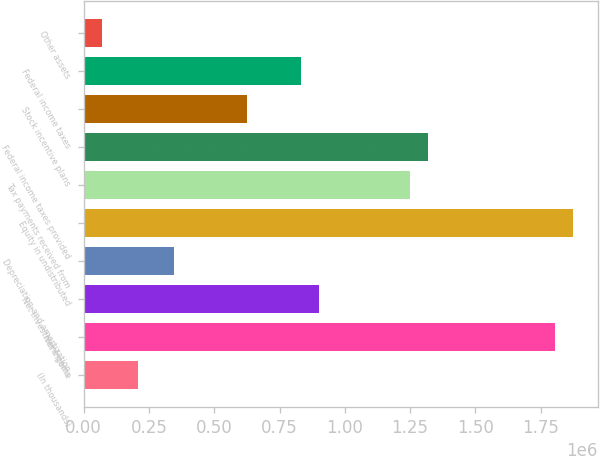<chart> <loc_0><loc_0><loc_500><loc_500><bar_chart><fcel>(In thousands)<fcel>Net income<fcel>Net investment gains<fcel>Depreciation and amortization<fcel>Equity in undistributed<fcel>Tax payments received from<fcel>Federal income taxes provided<fcel>Stock incentive plans<fcel>Federal income taxes<fcel>Other assets<nl><fcel>208478<fcel>1.80607e+06<fcel>903082<fcel>347399<fcel>1.87553e+06<fcel>1.25038e+06<fcel>1.31984e+06<fcel>625241<fcel>833622<fcel>69557.4<nl></chart> 